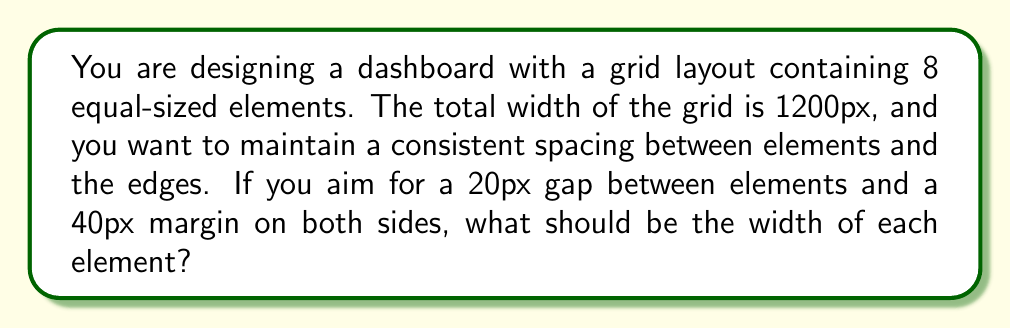Teach me how to tackle this problem. Let's approach this step-by-step:

1. Define variables:
   $w$ = width of each element
   $n$ = number of elements (8)
   $g$ = gap between elements (20px)
   $m$ = margin on each side (40px)
   $T$ = total width (1200px)

2. Set up the equation:
   Total width = Left margin + Element widths + Gaps + Right margin
   $$T = m + nw + (n-1)g + m$$

3. Substitute known values:
   $$1200 = 40 + 8w + (8-1)20 + 40$$

4. Simplify:
   $$1200 = 80 + 8w + 140$$
   $$1200 = 220 + 8w$$

5. Solve for $w$:
   $$8w = 1200 - 220$$
   $$8w = 980$$
   $$w = 980 \div 8 = 122.5$$

Therefore, each element should be 122.5px wide.

6. Verify:
   $$40 + (8 \times 122.5) + (7 \times 20) + 40 = 1200$$
   This confirms our calculation is correct.
Answer: 122.5px 